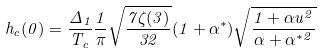<formula> <loc_0><loc_0><loc_500><loc_500>h _ { c } ( 0 ) = \frac { \Delta _ { 1 } } { T _ { c } } \frac { 1 } { \pi } \sqrt { \frac { 7 \zeta ( 3 ) } { 3 2 } } ( 1 + \alpha ^ { * } ) \sqrt { \frac { 1 + \alpha u ^ { 2 } } { \alpha + \alpha ^ { * 2 } } }</formula> 